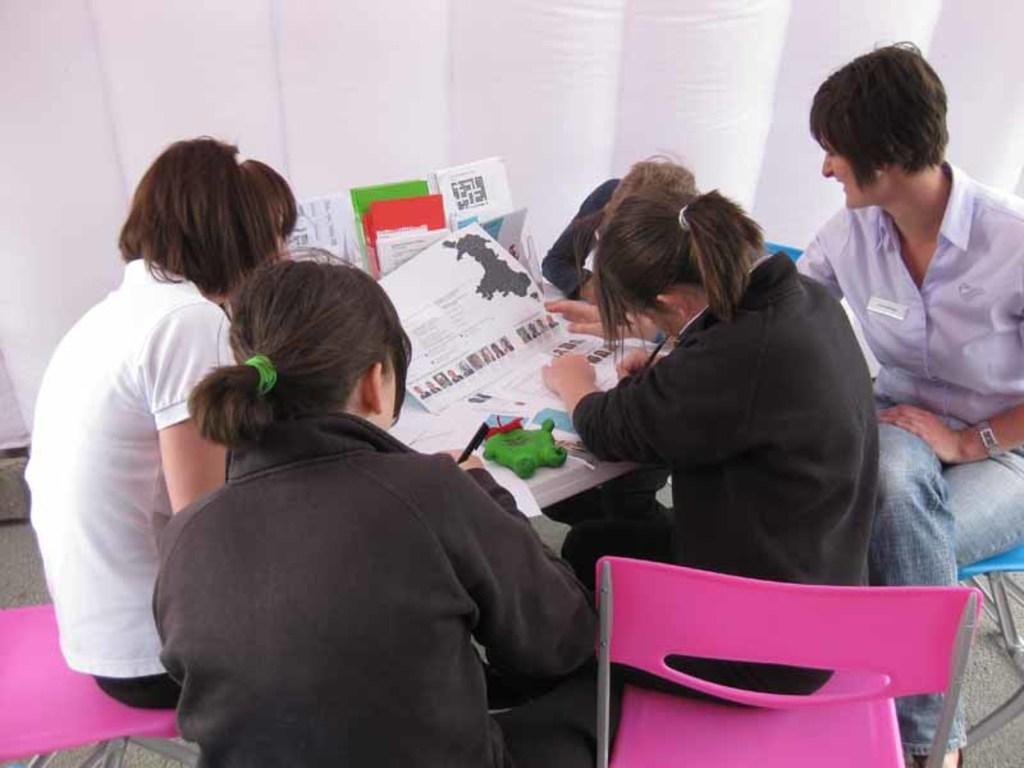In one or two sentences, can you explain what this image depicts? In the image we can see there are people who are sitting on chair and on the table there are papers. 